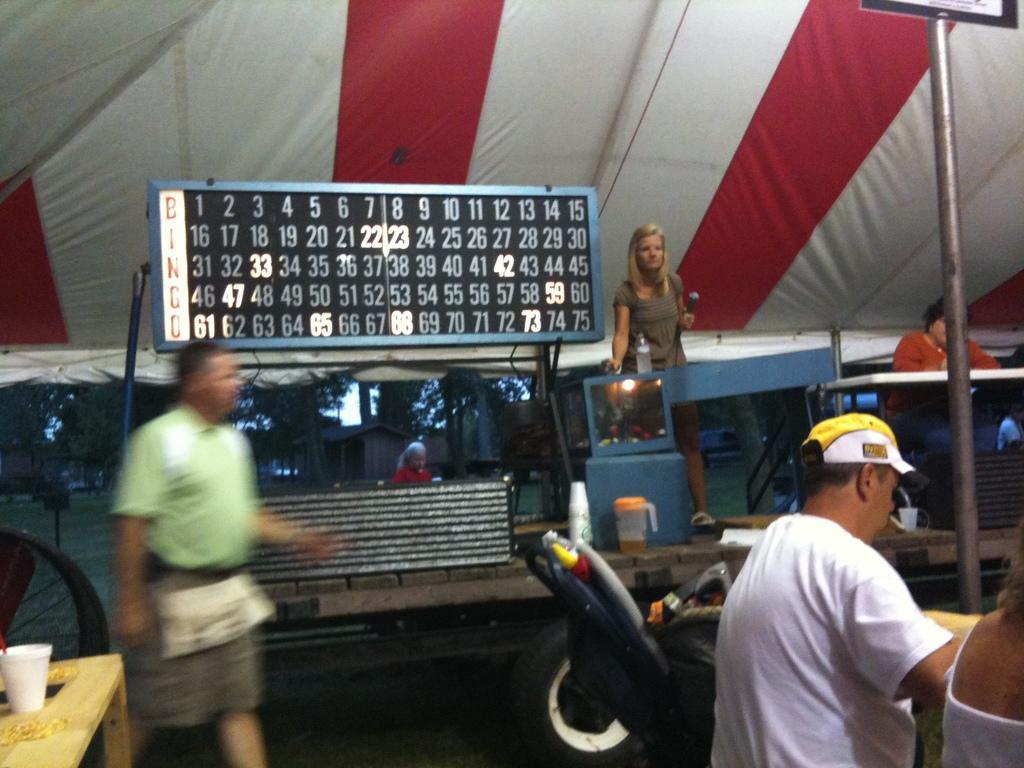Could you give a brief overview of what you see in this image? In this picture we can observe three members. Two of them were men and one of them was a woman. We can observe a black color board with numbers on it. We can observe a fabric roof which is in white and red color. There is a jar on the wooden table. In the background there are trees and a wooden house. 